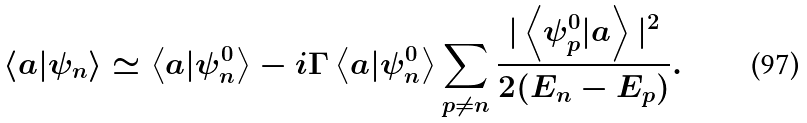<formula> <loc_0><loc_0><loc_500><loc_500>\left < a | \psi _ { n } \right > \simeq \left < a | \psi _ { n } ^ { 0 } \right > - i \Gamma \left < a | \psi _ { n } ^ { 0 } \right > \sum _ { p \neq n } \frac { | \left < \psi _ { p } ^ { 0 } | a \right > | ^ { 2 } } { 2 ( E _ { n } - E _ { p } ) } .</formula> 